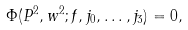Convert formula to latex. <formula><loc_0><loc_0><loc_500><loc_500>\Phi ( P ^ { 2 } , w ^ { 2 } ; f , j _ { 0 } , \dots , j _ { 3 } ) = 0 ,</formula> 